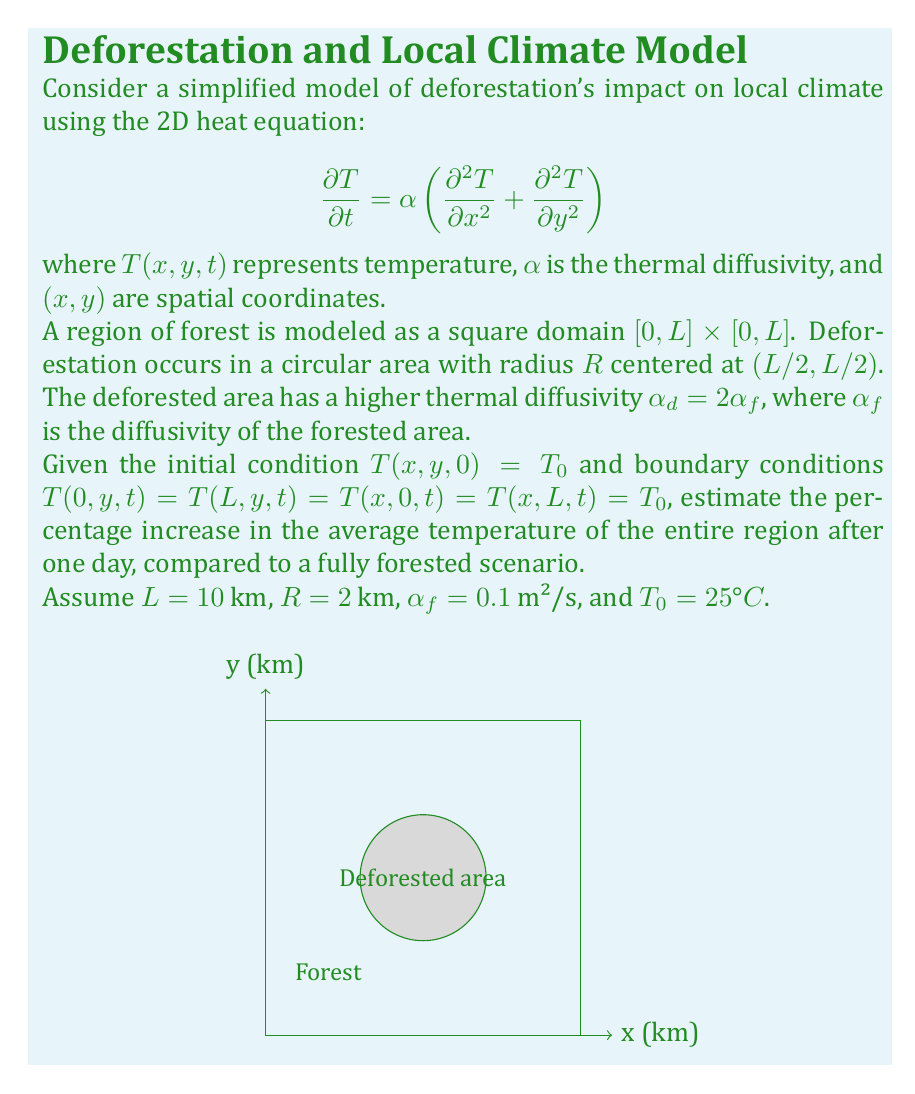Can you answer this question? To solve this problem, we'll follow these steps:

1) First, we need to calculate the average temperature increase in the deforested area and the forested area separately.

2) For the deforested area (circle), we can use the solution to the heat equation in polar coordinates:

   $$T(r,t) = T_0 + \Delta T \left(1 - e^{-\alpha_d t / R^2}\right)$$

   where $\Delta T$ is the temperature difference between the center and the edge of the circle.

3) For the forested area, we can use a similar equation with $\alpha_f$ instead of $\alpha_d$.

4) We don't know $\Delta T$, but we can estimate it based on typical temperature differences observed in deforested areas. Let's assume $\Delta T = 5°C$.

5) Calculate the temperature increase for the deforested area after one day:

   $$\Delta T_d = 5 \left(1 - e^{-2 \cdot 0.1 \cdot 86400 / (2000^2)}\right) = 0.864°C$$

6) Calculate the temperature increase for the forested area:

   $$\Delta T_f = 5 \left(1 - e^{-0.1 \cdot 86400 / (2000^2)}\right) = 0.432°C$$

7) Calculate the areas:
   Deforested area: $A_d = \pi R^2 = \pi \cdot 2^2 = 12.57$ km²
   Total area: $A_t = L^2 = 10^2 = 100$ km²
   Forested area: $A_f = A_t - A_d = 87.43$ km²

8) Calculate the weighted average temperature increase:

   $$\Delta T_{avg} = \frac{A_d \Delta T_d + A_f \Delta T_f}{A_t}$$
   $$\Delta T_{avg} = \frac{12.57 \cdot 0.864 + 87.43 \cdot 0.432}{100} = 0.486°C$$

9) Calculate the percentage increase:

   $$\text{Percentage increase} = \frac{0.486}{25} \cdot 100\% = 1.94\%$$
Answer: 1.94% 